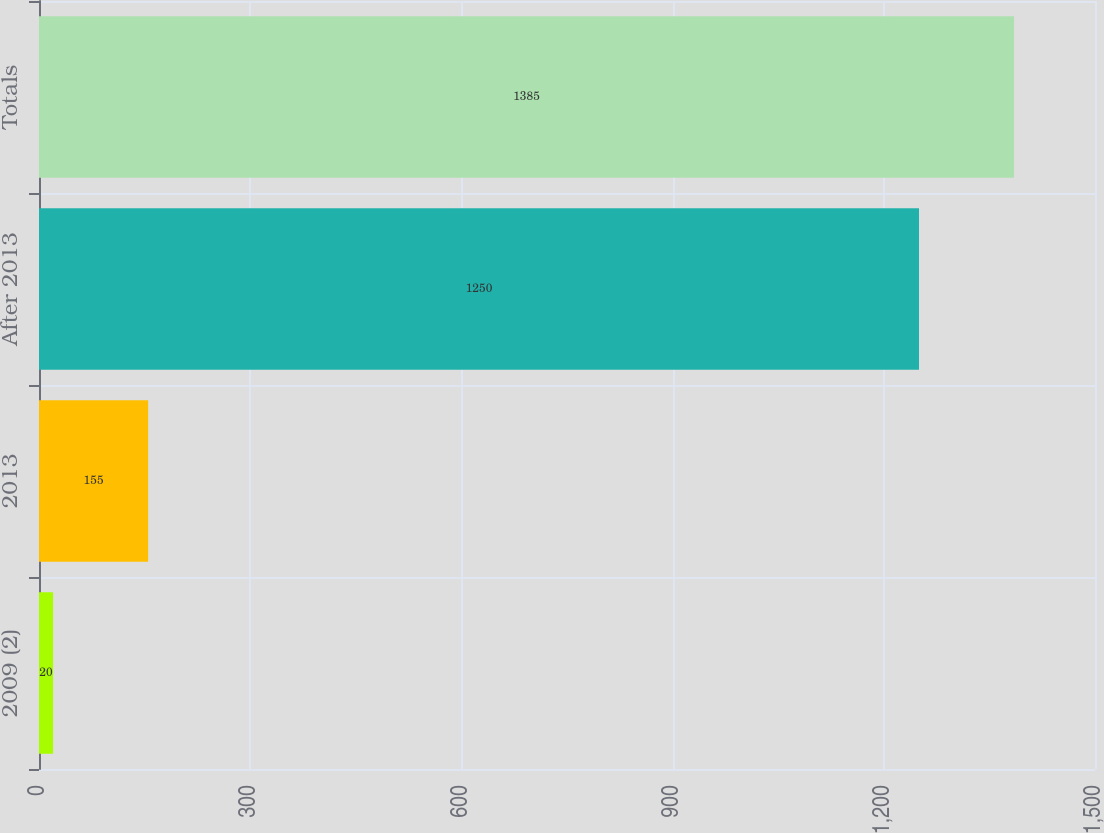Convert chart to OTSL. <chart><loc_0><loc_0><loc_500><loc_500><bar_chart><fcel>2009 (2)<fcel>2013<fcel>After 2013<fcel>Totals<nl><fcel>20<fcel>155<fcel>1250<fcel>1385<nl></chart> 